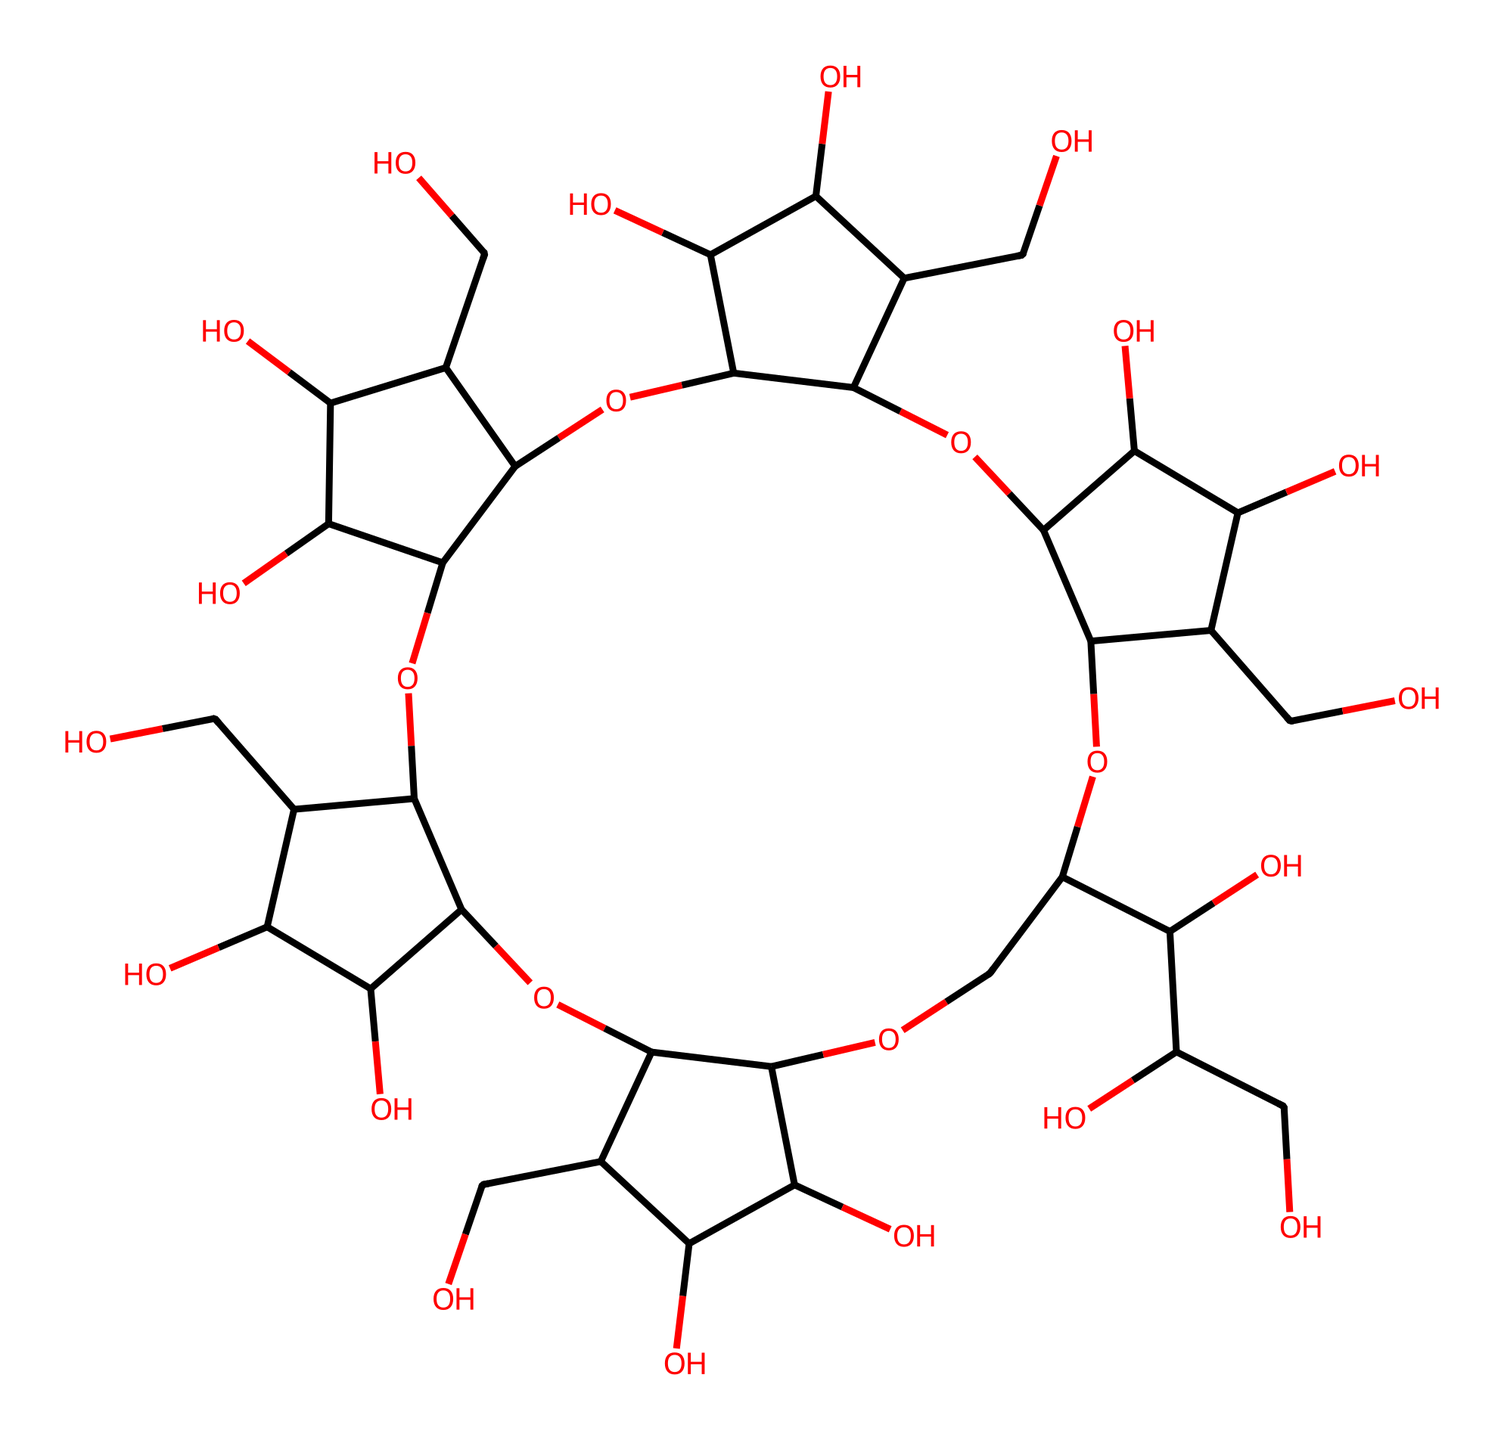What is the name of this chemical structure? This chemical is a cyclic oligosaccharide called alpha-cyclodextrin, which is a type of carbohydrate composed of a cyclic arrangement of glucose units.
Answer: alpha-cyclodextrin How many glucose units are present in this structure? By analyzing the structure, it can be observed that alpha-cyclodextrin consists of six glucose units connected in a cyclic manner, reflected in its composition.
Answer: six What functional groups are present in alpha-cyclodextrin? The primary functional groups are hydroxyl groups (-OH) attached to the glucose units. As seen in the structure, several -OH groups are evident throughout the compound.
Answer: hydroxyl groups What type of compound is alpha-cyclodextrin classified as? Alpha-cyclodextrin belongs to the class of compounds known as cage compounds due to its unique cyclic structure, which forms a cage-like configuration that can encapsulate other molecules.
Answer: cage compound How does the structure of alpha-cyclodextrin impact its solubility? The multiple hydroxyl groups increase the compound’s hydrophilicity, allowing it to dissolve well in water and enhancing its solubility based on the abundance of polar -OH groups in the structure.
Answer: increases solubility What is the primary use of alpha-cyclodextrin in dietary supplements? Alpha-cyclodextrin is commonly used as a dietary fiber supplement, leveraging its ability to encapsulate fats and enhance nutrient absorption, as indicated by its functional properties in the food industry.
Answer: dietary fiber supplement What property allows alpha-cyclodextrin to encapsulate other molecules? The unique clathrate structure created by its cyclic arrangement and numerous hydroxyl groups facilitates molecular encapsulation by providing a hydrophobic cavity that can trap smaller molecules.
Answer: clathrate structure 